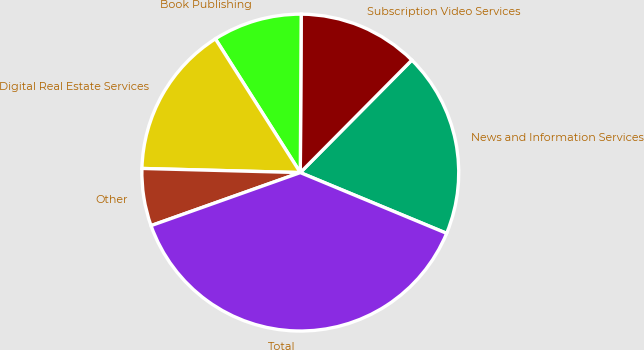Convert chart. <chart><loc_0><loc_0><loc_500><loc_500><pie_chart><fcel>News and Information Services<fcel>Subscription Video Services<fcel>Book Publishing<fcel>Digital Real Estate Services<fcel>Other<fcel>Total<nl><fcel>18.83%<fcel>12.34%<fcel>9.09%<fcel>15.58%<fcel>5.85%<fcel>38.3%<nl></chart> 